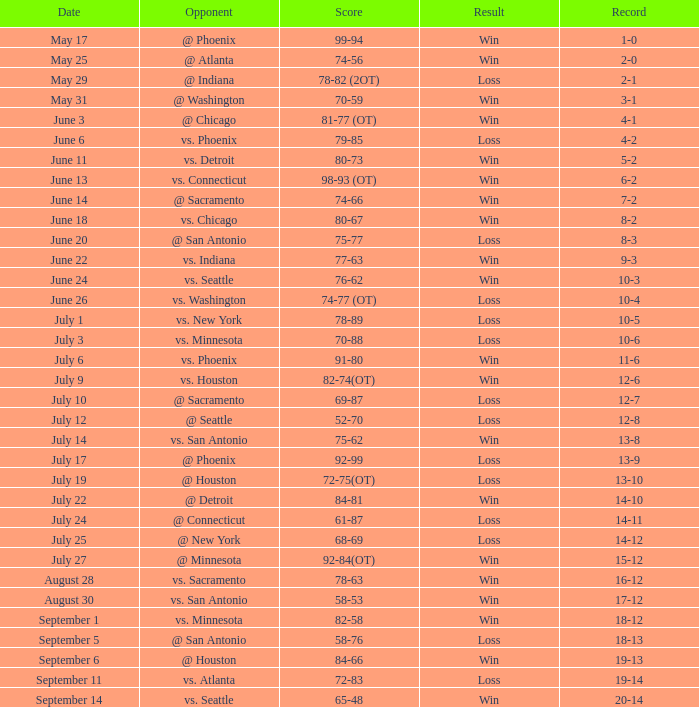What is the Record of the game on September 6? 19-13. 